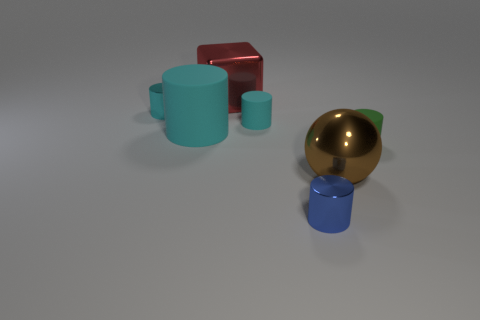Subtract all tiny cyan metal cylinders. How many cylinders are left? 4 Subtract 2 cylinders. How many cylinders are left? 3 Subtract all purple blocks. How many cyan cylinders are left? 3 Subtract all blue cylinders. How many cylinders are left? 4 Subtract all yellow cylinders. Subtract all cyan spheres. How many cylinders are left? 5 Add 1 small cyan matte spheres. How many objects exist? 8 Add 5 matte cylinders. How many matte cylinders are left? 8 Add 7 large green metal cubes. How many large green metal cubes exist? 7 Subtract 0 red balls. How many objects are left? 7 Subtract all cubes. How many objects are left? 6 